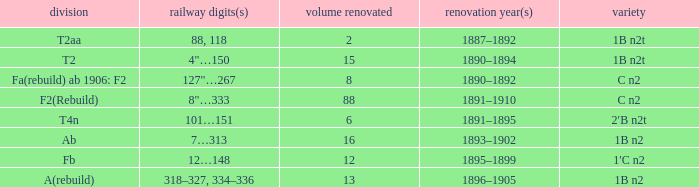What was the Rebuildjahr(e) for the T2AA class? 1887–1892. 